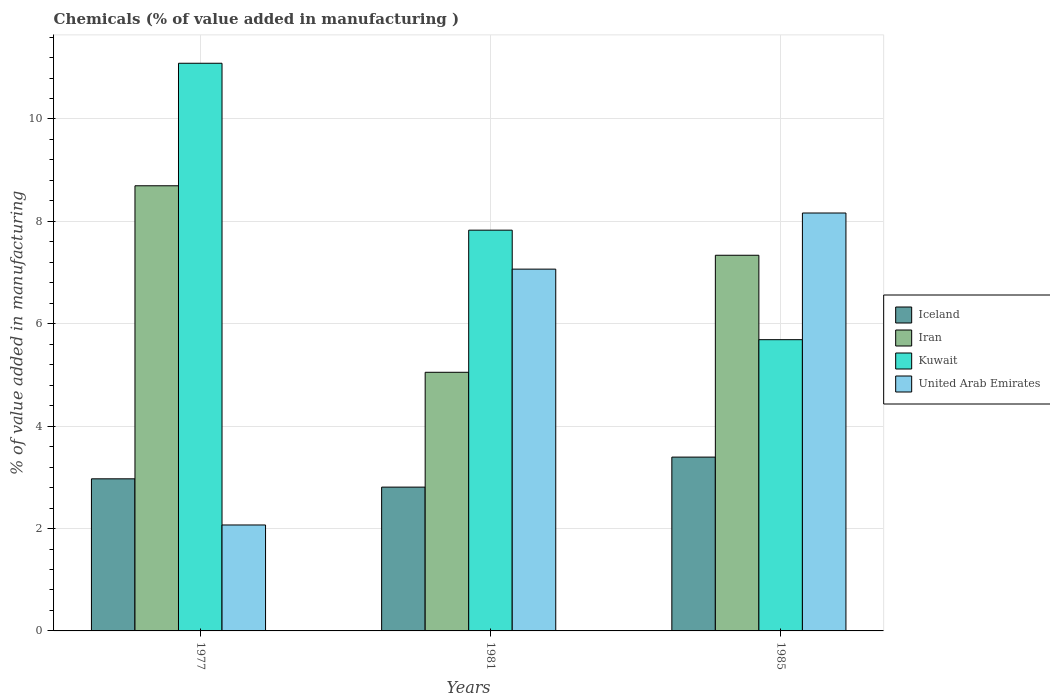Are the number of bars on each tick of the X-axis equal?
Keep it short and to the point. Yes. How many bars are there on the 2nd tick from the left?
Your answer should be compact. 4. What is the label of the 3rd group of bars from the left?
Provide a succinct answer. 1985. In how many cases, is the number of bars for a given year not equal to the number of legend labels?
Keep it short and to the point. 0. What is the value added in manufacturing chemicals in Iran in 1977?
Offer a terse response. 8.7. Across all years, what is the maximum value added in manufacturing chemicals in Kuwait?
Give a very brief answer. 11.09. Across all years, what is the minimum value added in manufacturing chemicals in Iceland?
Provide a succinct answer. 2.81. In which year was the value added in manufacturing chemicals in United Arab Emirates minimum?
Give a very brief answer. 1977. What is the total value added in manufacturing chemicals in Iceland in the graph?
Make the answer very short. 9.18. What is the difference between the value added in manufacturing chemicals in Iceland in 1977 and that in 1981?
Ensure brevity in your answer.  0.16. What is the difference between the value added in manufacturing chemicals in Iceland in 1981 and the value added in manufacturing chemicals in Kuwait in 1977?
Provide a short and direct response. -8.28. What is the average value added in manufacturing chemicals in Kuwait per year?
Your answer should be very brief. 8.2. In the year 1985, what is the difference between the value added in manufacturing chemicals in Kuwait and value added in manufacturing chemicals in United Arab Emirates?
Your response must be concise. -2.47. What is the ratio of the value added in manufacturing chemicals in Iran in 1981 to that in 1985?
Give a very brief answer. 0.69. Is the difference between the value added in manufacturing chemicals in Kuwait in 1977 and 1985 greater than the difference between the value added in manufacturing chemicals in United Arab Emirates in 1977 and 1985?
Ensure brevity in your answer.  Yes. What is the difference between the highest and the second highest value added in manufacturing chemicals in Kuwait?
Ensure brevity in your answer.  3.26. What is the difference between the highest and the lowest value added in manufacturing chemicals in Iran?
Give a very brief answer. 3.64. Is the sum of the value added in manufacturing chemicals in Iceland in 1977 and 1985 greater than the maximum value added in manufacturing chemicals in Kuwait across all years?
Your answer should be very brief. No. What does the 2nd bar from the left in 1977 represents?
Provide a short and direct response. Iran. What does the 2nd bar from the right in 1985 represents?
Make the answer very short. Kuwait. Are all the bars in the graph horizontal?
Provide a succinct answer. No. How many years are there in the graph?
Provide a succinct answer. 3. Are the values on the major ticks of Y-axis written in scientific E-notation?
Your answer should be very brief. No. Does the graph contain any zero values?
Provide a short and direct response. No. Does the graph contain grids?
Provide a succinct answer. Yes. How many legend labels are there?
Keep it short and to the point. 4. How are the legend labels stacked?
Give a very brief answer. Vertical. What is the title of the graph?
Provide a short and direct response. Chemicals (% of value added in manufacturing ). What is the label or title of the Y-axis?
Ensure brevity in your answer.  % of value added in manufacturing. What is the % of value added in manufacturing in Iceland in 1977?
Ensure brevity in your answer.  2.97. What is the % of value added in manufacturing in Iran in 1977?
Ensure brevity in your answer.  8.7. What is the % of value added in manufacturing in Kuwait in 1977?
Your response must be concise. 11.09. What is the % of value added in manufacturing in United Arab Emirates in 1977?
Offer a terse response. 2.07. What is the % of value added in manufacturing of Iceland in 1981?
Ensure brevity in your answer.  2.81. What is the % of value added in manufacturing in Iran in 1981?
Your answer should be very brief. 5.05. What is the % of value added in manufacturing in Kuwait in 1981?
Offer a very short reply. 7.83. What is the % of value added in manufacturing of United Arab Emirates in 1981?
Keep it short and to the point. 7.07. What is the % of value added in manufacturing of Iceland in 1985?
Keep it short and to the point. 3.4. What is the % of value added in manufacturing in Iran in 1985?
Your response must be concise. 7.34. What is the % of value added in manufacturing of Kuwait in 1985?
Provide a short and direct response. 5.69. What is the % of value added in manufacturing of United Arab Emirates in 1985?
Your answer should be compact. 8.16. Across all years, what is the maximum % of value added in manufacturing of Iceland?
Keep it short and to the point. 3.4. Across all years, what is the maximum % of value added in manufacturing of Iran?
Provide a short and direct response. 8.7. Across all years, what is the maximum % of value added in manufacturing of Kuwait?
Provide a succinct answer. 11.09. Across all years, what is the maximum % of value added in manufacturing in United Arab Emirates?
Your answer should be compact. 8.16. Across all years, what is the minimum % of value added in manufacturing in Iceland?
Your response must be concise. 2.81. Across all years, what is the minimum % of value added in manufacturing of Iran?
Offer a terse response. 5.05. Across all years, what is the minimum % of value added in manufacturing of Kuwait?
Your answer should be very brief. 5.69. Across all years, what is the minimum % of value added in manufacturing in United Arab Emirates?
Keep it short and to the point. 2.07. What is the total % of value added in manufacturing in Iceland in the graph?
Keep it short and to the point. 9.18. What is the total % of value added in manufacturing in Iran in the graph?
Give a very brief answer. 21.09. What is the total % of value added in manufacturing in Kuwait in the graph?
Give a very brief answer. 24.61. What is the total % of value added in manufacturing of United Arab Emirates in the graph?
Your response must be concise. 17.3. What is the difference between the % of value added in manufacturing in Iceland in 1977 and that in 1981?
Provide a succinct answer. 0.16. What is the difference between the % of value added in manufacturing in Iran in 1977 and that in 1981?
Offer a very short reply. 3.64. What is the difference between the % of value added in manufacturing in Kuwait in 1977 and that in 1981?
Offer a terse response. 3.26. What is the difference between the % of value added in manufacturing in United Arab Emirates in 1977 and that in 1981?
Offer a very short reply. -5. What is the difference between the % of value added in manufacturing in Iceland in 1977 and that in 1985?
Your response must be concise. -0.42. What is the difference between the % of value added in manufacturing in Iran in 1977 and that in 1985?
Your answer should be very brief. 1.36. What is the difference between the % of value added in manufacturing of Kuwait in 1977 and that in 1985?
Your answer should be compact. 5.4. What is the difference between the % of value added in manufacturing of United Arab Emirates in 1977 and that in 1985?
Your response must be concise. -6.09. What is the difference between the % of value added in manufacturing in Iceland in 1981 and that in 1985?
Your response must be concise. -0.59. What is the difference between the % of value added in manufacturing of Iran in 1981 and that in 1985?
Your answer should be very brief. -2.29. What is the difference between the % of value added in manufacturing of Kuwait in 1981 and that in 1985?
Offer a very short reply. 2.14. What is the difference between the % of value added in manufacturing in United Arab Emirates in 1981 and that in 1985?
Offer a very short reply. -1.1. What is the difference between the % of value added in manufacturing of Iceland in 1977 and the % of value added in manufacturing of Iran in 1981?
Offer a terse response. -2.08. What is the difference between the % of value added in manufacturing of Iceland in 1977 and the % of value added in manufacturing of Kuwait in 1981?
Your answer should be very brief. -4.86. What is the difference between the % of value added in manufacturing of Iceland in 1977 and the % of value added in manufacturing of United Arab Emirates in 1981?
Your answer should be very brief. -4.1. What is the difference between the % of value added in manufacturing in Iran in 1977 and the % of value added in manufacturing in Kuwait in 1981?
Keep it short and to the point. 0.87. What is the difference between the % of value added in manufacturing of Iran in 1977 and the % of value added in manufacturing of United Arab Emirates in 1981?
Give a very brief answer. 1.63. What is the difference between the % of value added in manufacturing of Kuwait in 1977 and the % of value added in manufacturing of United Arab Emirates in 1981?
Offer a terse response. 4.02. What is the difference between the % of value added in manufacturing in Iceland in 1977 and the % of value added in manufacturing in Iran in 1985?
Make the answer very short. -4.37. What is the difference between the % of value added in manufacturing of Iceland in 1977 and the % of value added in manufacturing of Kuwait in 1985?
Ensure brevity in your answer.  -2.72. What is the difference between the % of value added in manufacturing in Iceland in 1977 and the % of value added in manufacturing in United Arab Emirates in 1985?
Offer a very short reply. -5.19. What is the difference between the % of value added in manufacturing of Iran in 1977 and the % of value added in manufacturing of Kuwait in 1985?
Provide a short and direct response. 3.01. What is the difference between the % of value added in manufacturing in Iran in 1977 and the % of value added in manufacturing in United Arab Emirates in 1985?
Provide a succinct answer. 0.53. What is the difference between the % of value added in manufacturing of Kuwait in 1977 and the % of value added in manufacturing of United Arab Emirates in 1985?
Ensure brevity in your answer.  2.93. What is the difference between the % of value added in manufacturing of Iceland in 1981 and the % of value added in manufacturing of Iran in 1985?
Provide a short and direct response. -4.53. What is the difference between the % of value added in manufacturing of Iceland in 1981 and the % of value added in manufacturing of Kuwait in 1985?
Keep it short and to the point. -2.88. What is the difference between the % of value added in manufacturing of Iceland in 1981 and the % of value added in manufacturing of United Arab Emirates in 1985?
Keep it short and to the point. -5.35. What is the difference between the % of value added in manufacturing of Iran in 1981 and the % of value added in manufacturing of Kuwait in 1985?
Your response must be concise. -0.64. What is the difference between the % of value added in manufacturing in Iran in 1981 and the % of value added in manufacturing in United Arab Emirates in 1985?
Your response must be concise. -3.11. What is the difference between the % of value added in manufacturing of Kuwait in 1981 and the % of value added in manufacturing of United Arab Emirates in 1985?
Offer a terse response. -0.34. What is the average % of value added in manufacturing in Iceland per year?
Your answer should be compact. 3.06. What is the average % of value added in manufacturing in Iran per year?
Your answer should be compact. 7.03. What is the average % of value added in manufacturing in Kuwait per year?
Ensure brevity in your answer.  8.2. What is the average % of value added in manufacturing of United Arab Emirates per year?
Make the answer very short. 5.77. In the year 1977, what is the difference between the % of value added in manufacturing of Iceland and % of value added in manufacturing of Iran?
Your answer should be compact. -5.72. In the year 1977, what is the difference between the % of value added in manufacturing in Iceland and % of value added in manufacturing in Kuwait?
Ensure brevity in your answer.  -8.12. In the year 1977, what is the difference between the % of value added in manufacturing in Iceland and % of value added in manufacturing in United Arab Emirates?
Provide a short and direct response. 0.9. In the year 1977, what is the difference between the % of value added in manufacturing in Iran and % of value added in manufacturing in Kuwait?
Give a very brief answer. -2.39. In the year 1977, what is the difference between the % of value added in manufacturing of Iran and % of value added in manufacturing of United Arab Emirates?
Offer a very short reply. 6.63. In the year 1977, what is the difference between the % of value added in manufacturing of Kuwait and % of value added in manufacturing of United Arab Emirates?
Your response must be concise. 9.02. In the year 1981, what is the difference between the % of value added in manufacturing in Iceland and % of value added in manufacturing in Iran?
Ensure brevity in your answer.  -2.24. In the year 1981, what is the difference between the % of value added in manufacturing of Iceland and % of value added in manufacturing of Kuwait?
Your response must be concise. -5.02. In the year 1981, what is the difference between the % of value added in manufacturing of Iceland and % of value added in manufacturing of United Arab Emirates?
Provide a succinct answer. -4.26. In the year 1981, what is the difference between the % of value added in manufacturing of Iran and % of value added in manufacturing of Kuwait?
Offer a very short reply. -2.78. In the year 1981, what is the difference between the % of value added in manufacturing in Iran and % of value added in manufacturing in United Arab Emirates?
Your answer should be very brief. -2.02. In the year 1981, what is the difference between the % of value added in manufacturing of Kuwait and % of value added in manufacturing of United Arab Emirates?
Your answer should be very brief. 0.76. In the year 1985, what is the difference between the % of value added in manufacturing in Iceland and % of value added in manufacturing in Iran?
Your answer should be very brief. -3.94. In the year 1985, what is the difference between the % of value added in manufacturing in Iceland and % of value added in manufacturing in Kuwait?
Ensure brevity in your answer.  -2.29. In the year 1985, what is the difference between the % of value added in manufacturing of Iceland and % of value added in manufacturing of United Arab Emirates?
Your answer should be compact. -4.77. In the year 1985, what is the difference between the % of value added in manufacturing of Iran and % of value added in manufacturing of Kuwait?
Make the answer very short. 1.65. In the year 1985, what is the difference between the % of value added in manufacturing of Iran and % of value added in manufacturing of United Arab Emirates?
Offer a very short reply. -0.83. In the year 1985, what is the difference between the % of value added in manufacturing of Kuwait and % of value added in manufacturing of United Arab Emirates?
Offer a terse response. -2.47. What is the ratio of the % of value added in manufacturing of Iceland in 1977 to that in 1981?
Make the answer very short. 1.06. What is the ratio of the % of value added in manufacturing in Iran in 1977 to that in 1981?
Your response must be concise. 1.72. What is the ratio of the % of value added in manufacturing in Kuwait in 1977 to that in 1981?
Provide a short and direct response. 1.42. What is the ratio of the % of value added in manufacturing of United Arab Emirates in 1977 to that in 1981?
Ensure brevity in your answer.  0.29. What is the ratio of the % of value added in manufacturing in Iceland in 1977 to that in 1985?
Provide a succinct answer. 0.88. What is the ratio of the % of value added in manufacturing of Iran in 1977 to that in 1985?
Provide a short and direct response. 1.19. What is the ratio of the % of value added in manufacturing of Kuwait in 1977 to that in 1985?
Offer a terse response. 1.95. What is the ratio of the % of value added in manufacturing of United Arab Emirates in 1977 to that in 1985?
Offer a very short reply. 0.25. What is the ratio of the % of value added in manufacturing of Iceland in 1981 to that in 1985?
Provide a short and direct response. 0.83. What is the ratio of the % of value added in manufacturing of Iran in 1981 to that in 1985?
Keep it short and to the point. 0.69. What is the ratio of the % of value added in manufacturing of Kuwait in 1981 to that in 1985?
Your response must be concise. 1.38. What is the ratio of the % of value added in manufacturing of United Arab Emirates in 1981 to that in 1985?
Make the answer very short. 0.87. What is the difference between the highest and the second highest % of value added in manufacturing in Iceland?
Offer a terse response. 0.42. What is the difference between the highest and the second highest % of value added in manufacturing in Iran?
Your answer should be compact. 1.36. What is the difference between the highest and the second highest % of value added in manufacturing of Kuwait?
Ensure brevity in your answer.  3.26. What is the difference between the highest and the second highest % of value added in manufacturing of United Arab Emirates?
Provide a short and direct response. 1.1. What is the difference between the highest and the lowest % of value added in manufacturing of Iceland?
Provide a succinct answer. 0.59. What is the difference between the highest and the lowest % of value added in manufacturing of Iran?
Offer a terse response. 3.64. What is the difference between the highest and the lowest % of value added in manufacturing in Kuwait?
Give a very brief answer. 5.4. What is the difference between the highest and the lowest % of value added in manufacturing in United Arab Emirates?
Keep it short and to the point. 6.09. 